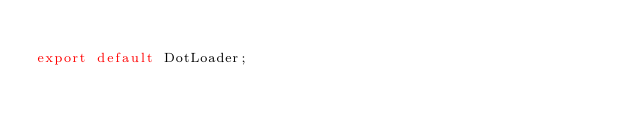Convert code to text. <code><loc_0><loc_0><loc_500><loc_500><_JavaScript_>
export default DotLoader;
</code> 